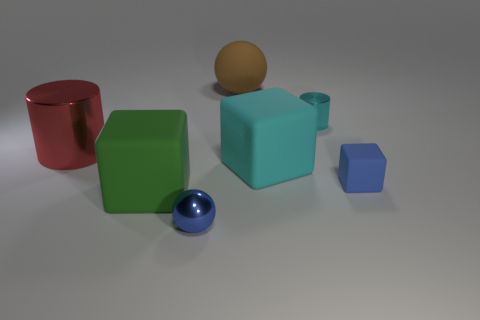Subtract all cyan blocks. How many blocks are left? 2 Subtract 1 spheres. How many spheres are left? 1 Add 2 large blue metal objects. How many objects exist? 9 Subtract all red cylinders. How many cylinders are left? 1 Add 7 big purple balls. How many big purple balls exist? 7 Subtract 0 yellow cylinders. How many objects are left? 7 Subtract all blocks. How many objects are left? 4 Subtract all purple cubes. Subtract all cyan cylinders. How many cubes are left? 3 Subtract all gray cylinders. How many brown spheres are left? 1 Subtract all matte objects. Subtract all large red metallic cylinders. How many objects are left? 2 